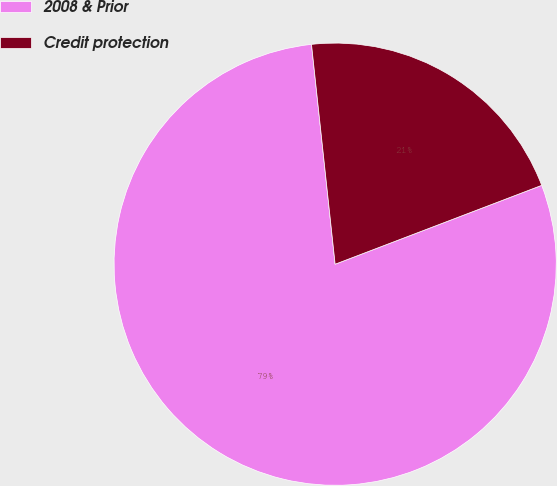<chart> <loc_0><loc_0><loc_500><loc_500><pie_chart><fcel>2008 & Prior<fcel>Credit protection<nl><fcel>79.1%<fcel>20.9%<nl></chart> 